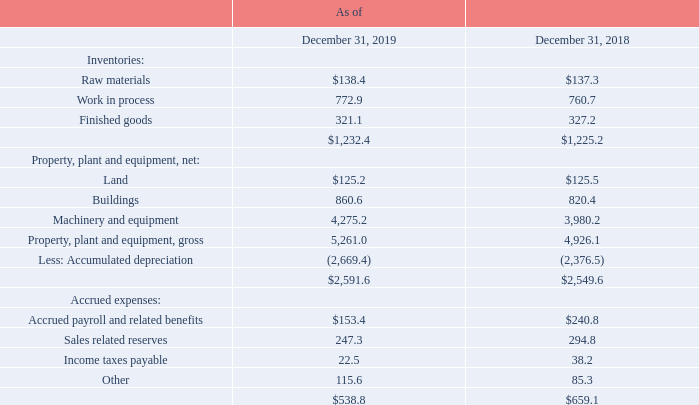Note 8: Balance Sheet Information
Certain significant amounts included in the Company's Consolidated Balance Sheets consist of the following (in millions):
Assets classified as held-for-sale, consisting primarily of properties, are required to be recorded at the lower of carrying value or fair value less any costs to sell. The carrying value of these assets as of December 31, 2019 was $1.4 million, and is reported as other current assets on the Company’s Consolidated Balance Sheet.
Depreciation expense for property, plant and equipment, including amortization of finance leases, totaled $409.7 million, $359.3 million and $325.2 million for 2019, 2018 and 2017, respectively.
Included within sales related reserves are ship and credit reserves for distributors amounting to $178.7 million and $230.8 million as of December 31, 2019 and 2018, respectively.
How much is the Depreciation expense for property, plant and equipment, including amortization of finance leases for 2019? $409.7 million. How much is the Depreciation expense for property, plant and equipment, including amortization of finance leases for 2018? $359.3 million. How much is the Depreciation expense for property, plant and equipment, including amortization of finance leases for 2017? $325.2 million. What is the change in Inventories: Work in process from December 31, 2018 to 2019?
Answer scale should be: million. 772.9-760.7
Answer: 12.2. What is the change in Inventories: Finished goods from year ended December 31, 2018 to 2019?
Answer scale should be: million. 321.1-327.2
Answer: -6.1. What is the average Inventories: Work in process for December 31, 2018 to 2019?
Answer scale should be: million. (772.9+760.7) / 2
Answer: 766.8. 